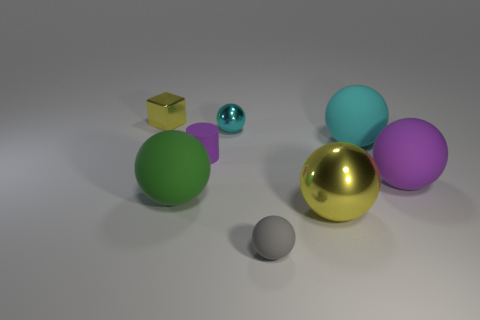What is the material of the other ball that is the same color as the small metallic ball?
Your answer should be very brief. Rubber. Are there any tiny gray rubber things left of the tiny purple cylinder?
Offer a very short reply. No. Do the big ball that is in front of the green rubber thing and the matte sphere to the left of the small gray object have the same color?
Give a very brief answer. No. Are there any small rubber things that have the same shape as the cyan metal object?
Your answer should be compact. Yes. How many other objects are the same color as the tiny rubber cylinder?
Your response must be concise. 1. What color is the small thing in front of the yellow metal object in front of the yellow thing behind the large cyan rubber ball?
Provide a succinct answer. Gray. Are there an equal number of green balls that are behind the tiny purple thing and tiny green rubber spheres?
Your response must be concise. Yes. Do the yellow thing in front of the purple matte sphere and the large cyan rubber object have the same size?
Your answer should be compact. Yes. How many tiny rubber cylinders are there?
Provide a succinct answer. 1. What number of things are behind the tiny cyan shiny thing and right of the big yellow ball?
Your response must be concise. 0. 